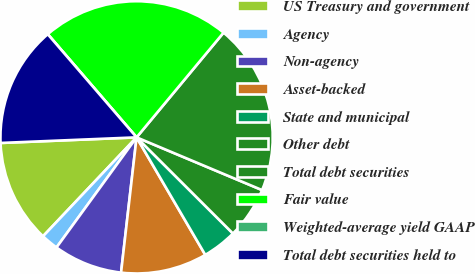<chart> <loc_0><loc_0><loc_500><loc_500><pie_chart><fcel>US Treasury and government<fcel>Agency<fcel>Non-agency<fcel>Asset-backed<fcel>State and municipal<fcel>Other debt<fcel>Total debt securities<fcel>Fair value<fcel>Weighted-average yield GAAP<fcel>Total debt securities held to<nl><fcel>12.29%<fcel>2.05%<fcel>8.19%<fcel>10.24%<fcel>4.1%<fcel>6.15%<fcel>20.3%<fcel>22.35%<fcel>0.0%<fcel>14.34%<nl></chart> 